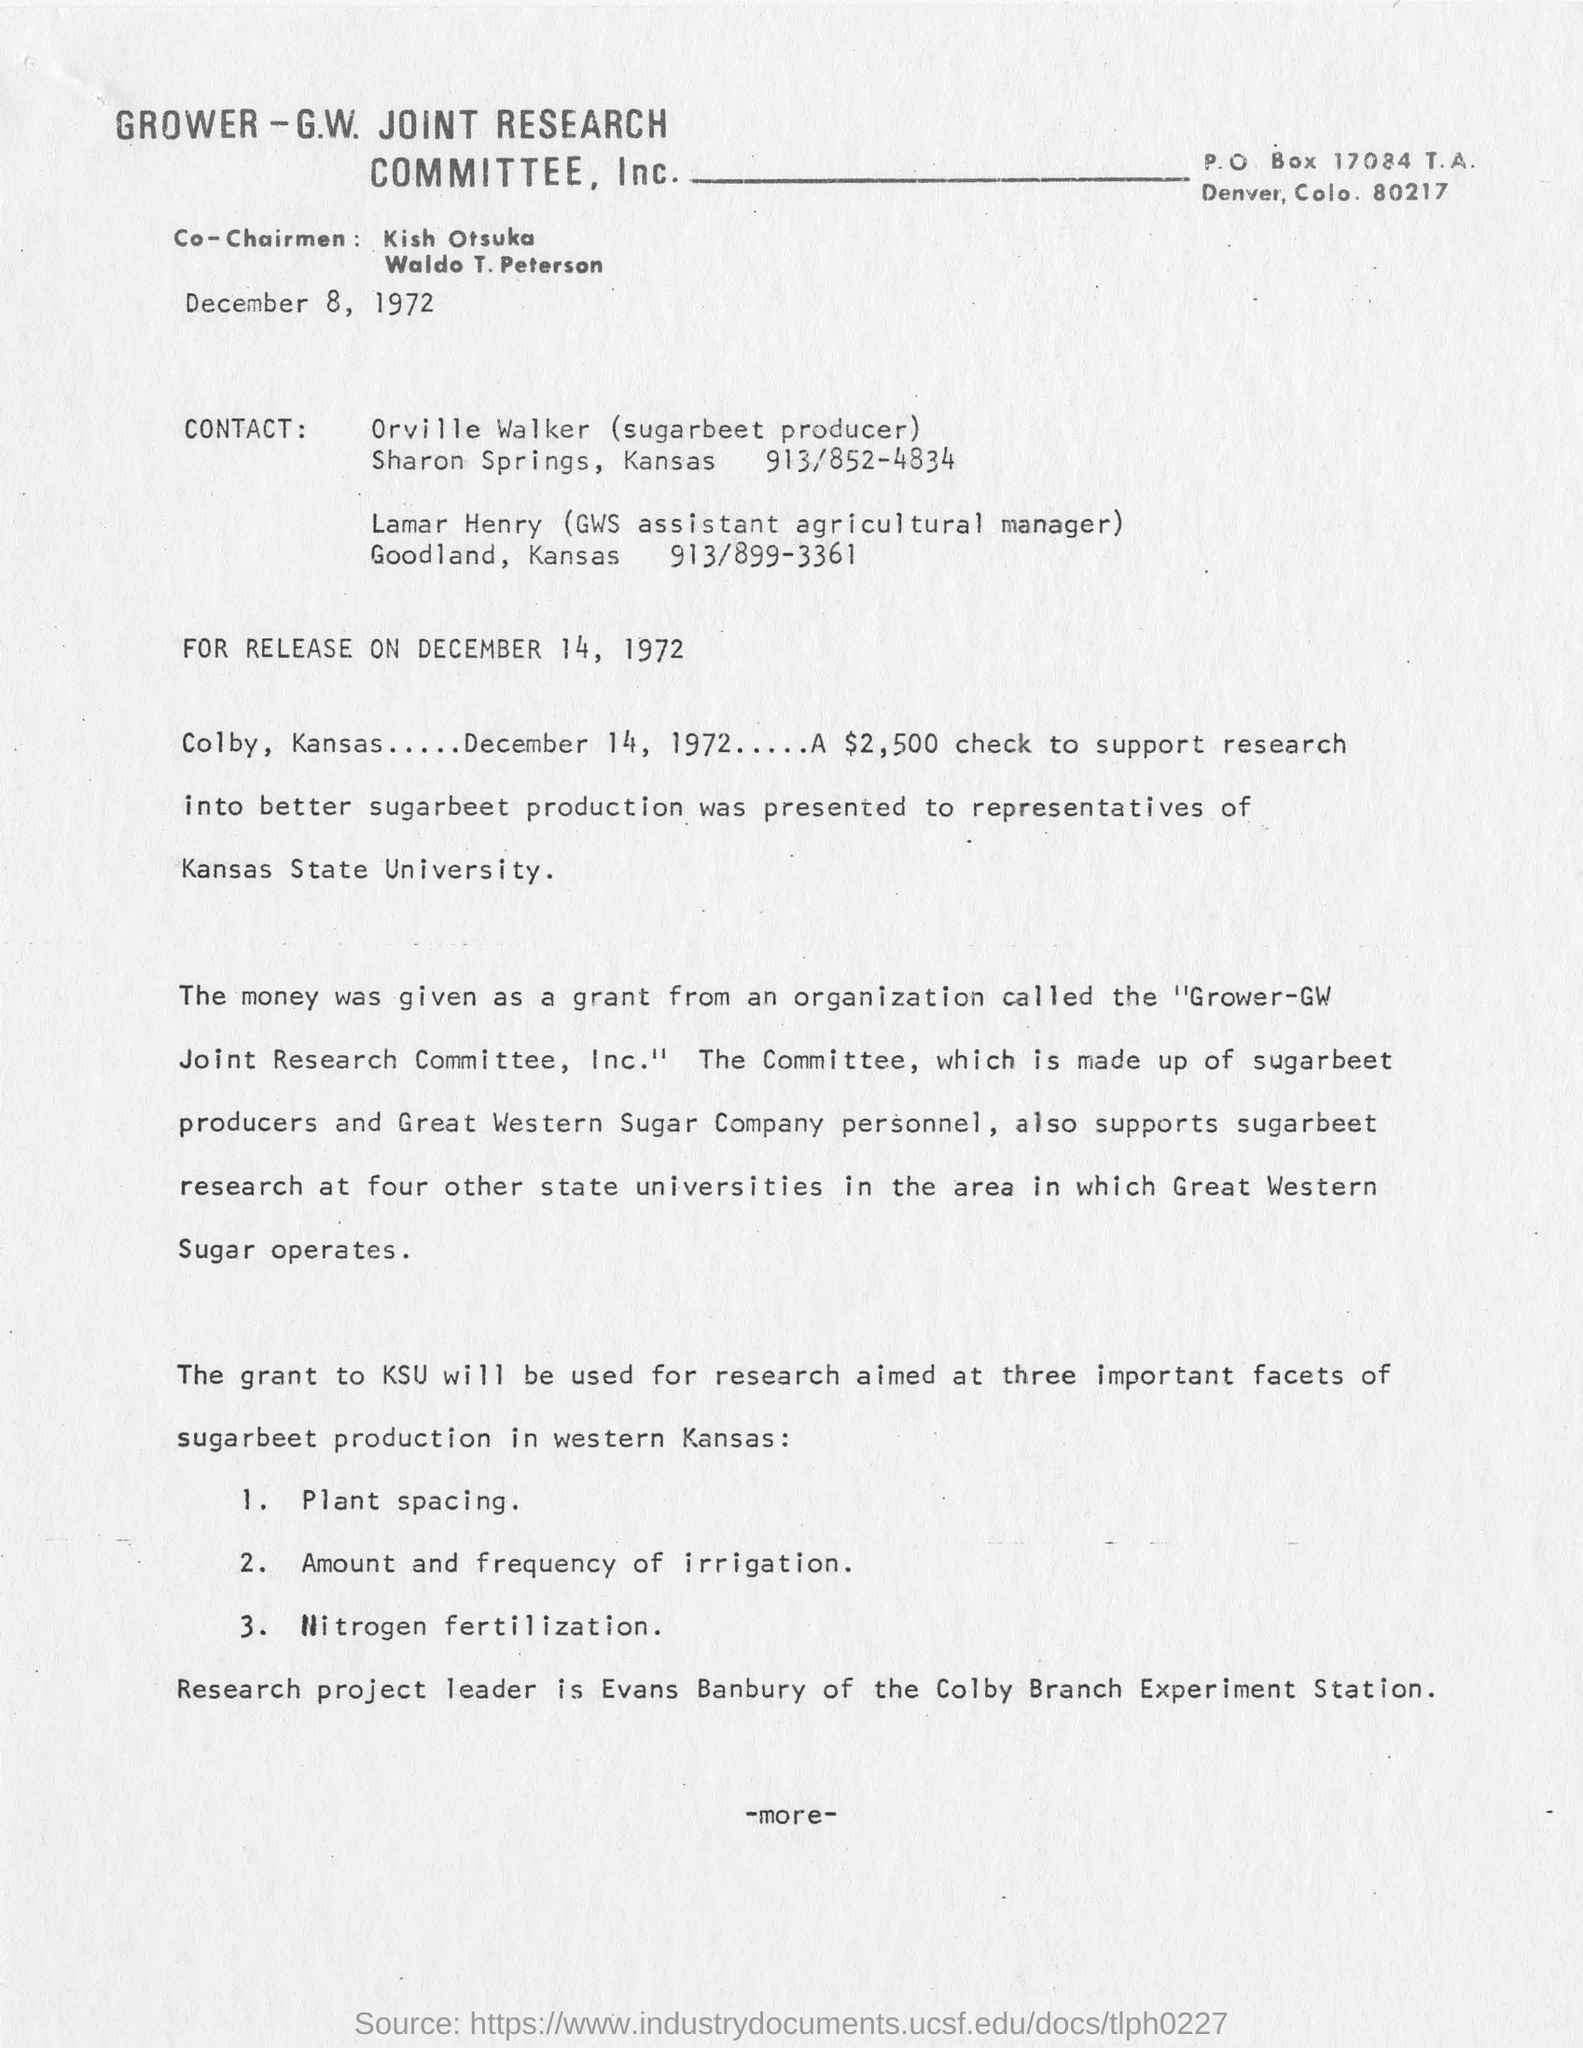Indicate a few pertinent items in this graphic. Lamar Henry is the assistant agricultural manager at GWS in Goodland, Kansas. On behalf of Kansas State University, a $2,500 check was presented to support research into improved sugarbeet production. The leader of the research project is Evans Banbury, who is affiliated with the Colby Branch Experiment Station. The letter is dated December 8, 1972. 